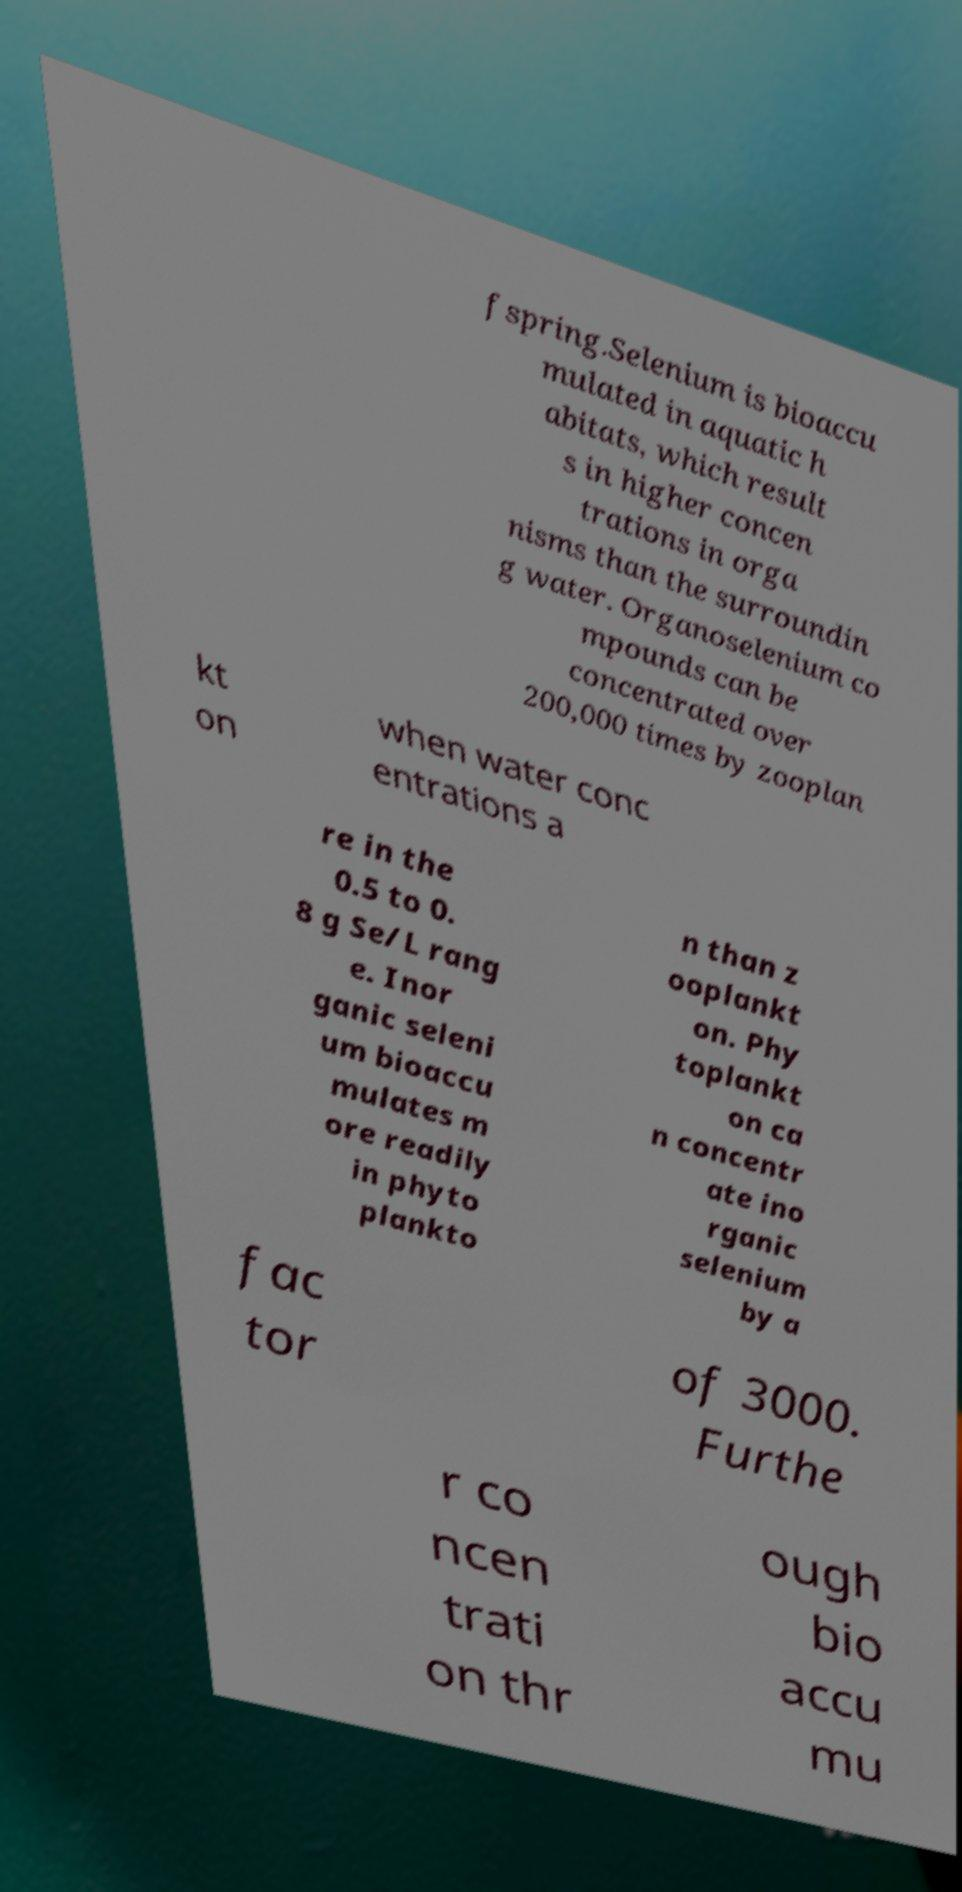I need the written content from this picture converted into text. Can you do that? fspring.Selenium is bioaccu mulated in aquatic h abitats, which result s in higher concen trations in orga nisms than the surroundin g water. Organoselenium co mpounds can be concentrated over 200,000 times by zooplan kt on when water conc entrations a re in the 0.5 to 0. 8 g Se/L rang e. Inor ganic seleni um bioaccu mulates m ore readily in phyto plankto n than z ooplankt on. Phy toplankt on ca n concentr ate ino rganic selenium by a fac tor of 3000. Furthe r co ncen trati on thr ough bio accu mu 